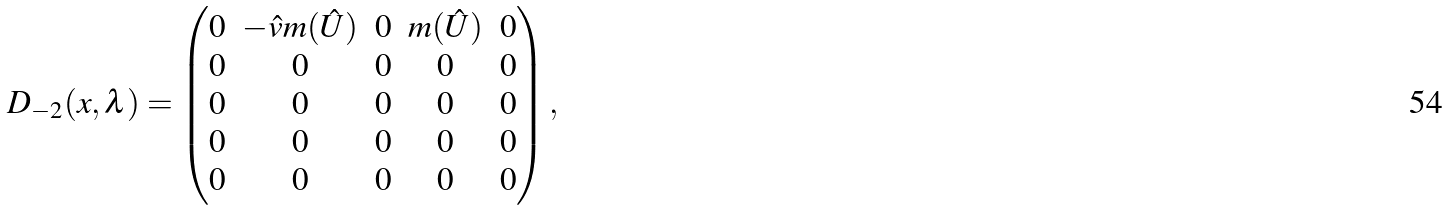<formula> <loc_0><loc_0><loc_500><loc_500>D _ { - 2 } ( x , \lambda ) = \begin{pmatrix} 0 & - \hat { v } m ( \hat { U } ) & 0 & m ( \hat { U } ) & 0 \\ 0 & 0 & 0 & 0 & 0 \\ 0 & 0 & 0 & 0 & 0 \\ 0 & 0 & 0 & 0 & 0 \\ 0 & 0 & 0 & 0 & 0 \\ \end{pmatrix} ,</formula> 